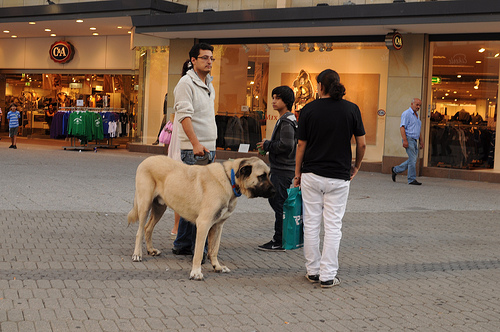What is the animal that the man to the left of the woman is holding onto? The animal that the man to the left of the woman is holding onto is a dog, which seems to be part of their group. 